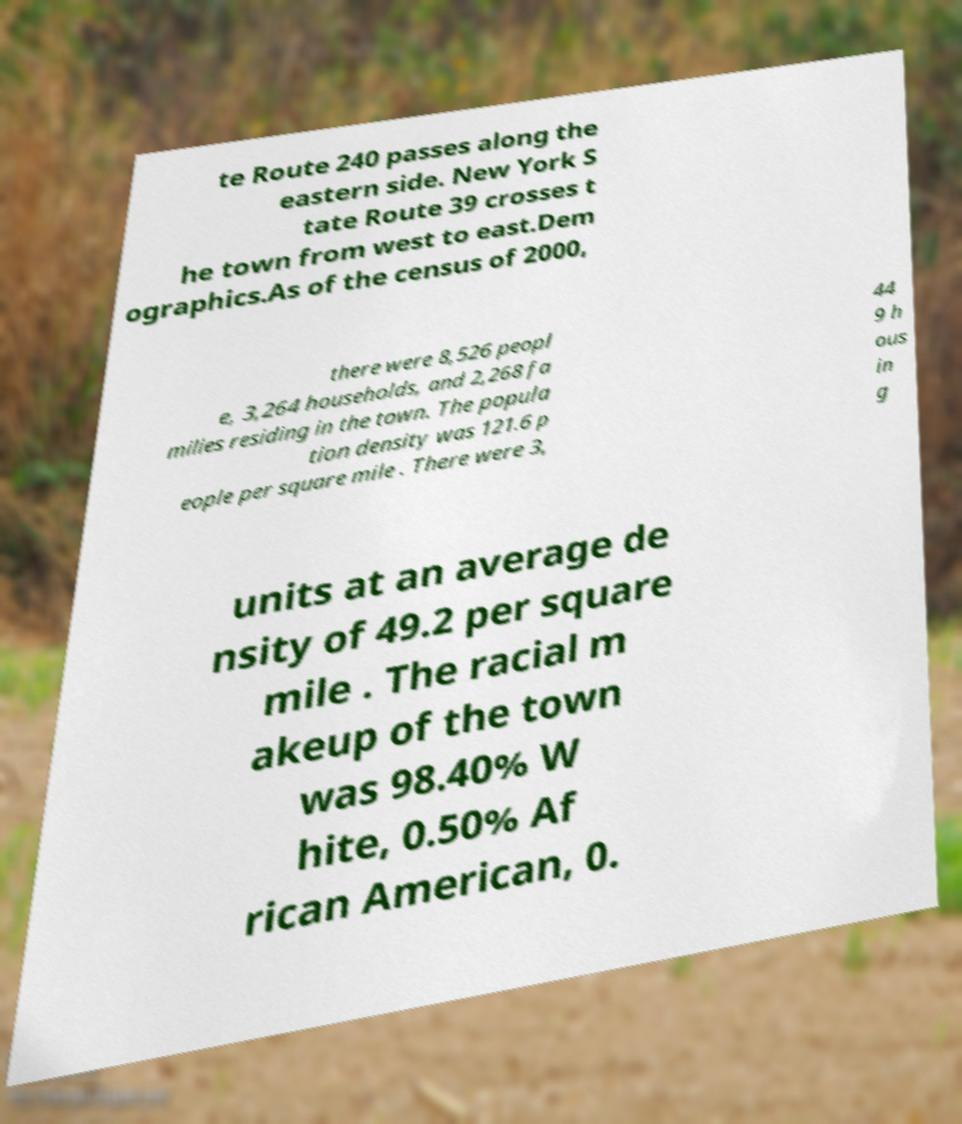There's text embedded in this image that I need extracted. Can you transcribe it verbatim? te Route 240 passes along the eastern side. New York S tate Route 39 crosses t he town from west to east.Dem ographics.As of the census of 2000, there were 8,526 peopl e, 3,264 households, and 2,268 fa milies residing in the town. The popula tion density was 121.6 p eople per square mile . There were 3, 44 9 h ous in g units at an average de nsity of 49.2 per square mile . The racial m akeup of the town was 98.40% W hite, 0.50% Af rican American, 0. 